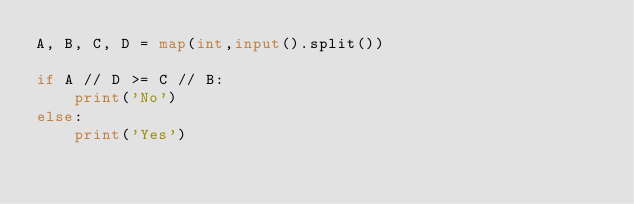Convert code to text. <code><loc_0><loc_0><loc_500><loc_500><_Python_>A, B, C, D = map(int,input().split())

if A // D >= C // B:
    print('No')
else:
    print('Yes')
</code> 